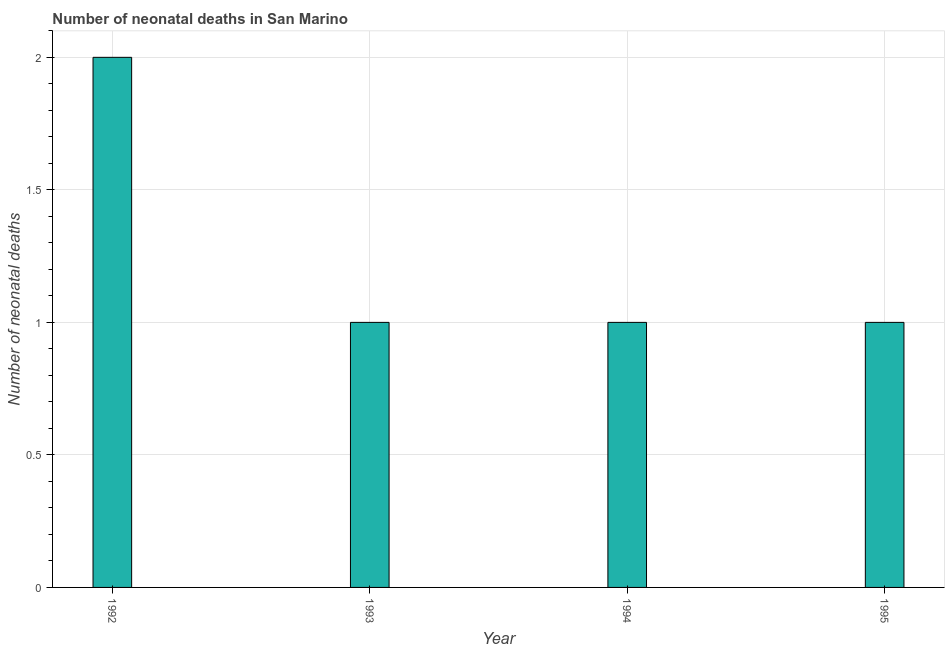What is the title of the graph?
Make the answer very short. Number of neonatal deaths in San Marino. What is the label or title of the Y-axis?
Your response must be concise. Number of neonatal deaths. What is the number of neonatal deaths in 1995?
Give a very brief answer. 1. In which year was the number of neonatal deaths minimum?
Provide a short and direct response. 1993. What is the sum of the number of neonatal deaths?
Make the answer very short. 5. In how many years, is the number of neonatal deaths greater than 1.6 ?
Give a very brief answer. 1. Do a majority of the years between 1993 and 1995 (inclusive) have number of neonatal deaths greater than 1 ?
Provide a succinct answer. No. What is the ratio of the number of neonatal deaths in 1992 to that in 1995?
Provide a succinct answer. 2. Is the number of neonatal deaths in 1992 less than that in 1995?
Offer a very short reply. No. What is the difference between the highest and the second highest number of neonatal deaths?
Make the answer very short. 1. Is the sum of the number of neonatal deaths in 1994 and 1995 greater than the maximum number of neonatal deaths across all years?
Your response must be concise. No. In how many years, is the number of neonatal deaths greater than the average number of neonatal deaths taken over all years?
Keep it short and to the point. 1. How many bars are there?
Give a very brief answer. 4. What is the difference between two consecutive major ticks on the Y-axis?
Offer a very short reply. 0.5. What is the Number of neonatal deaths of 1994?
Give a very brief answer. 1. What is the difference between the Number of neonatal deaths in 1992 and 1993?
Your answer should be compact. 1. What is the difference between the Number of neonatal deaths in 1992 and 1995?
Make the answer very short. 1. What is the difference between the Number of neonatal deaths in 1993 and 1994?
Provide a short and direct response. 0. What is the difference between the Number of neonatal deaths in 1993 and 1995?
Provide a short and direct response. 0. What is the difference between the Number of neonatal deaths in 1994 and 1995?
Keep it short and to the point. 0. What is the ratio of the Number of neonatal deaths in 1992 to that in 1993?
Your answer should be very brief. 2. What is the ratio of the Number of neonatal deaths in 1992 to that in 1994?
Make the answer very short. 2. What is the ratio of the Number of neonatal deaths in 1992 to that in 1995?
Offer a terse response. 2. What is the ratio of the Number of neonatal deaths in 1993 to that in 1994?
Offer a terse response. 1. 